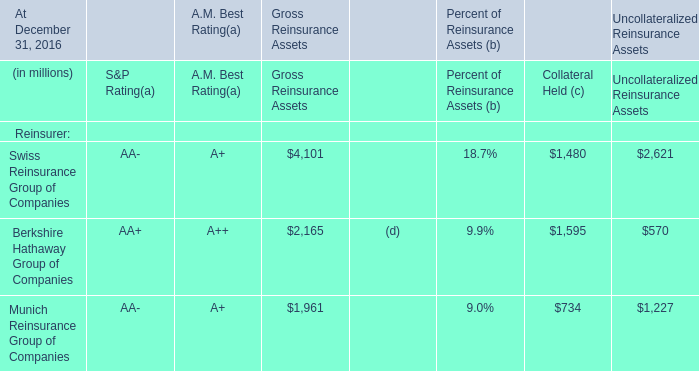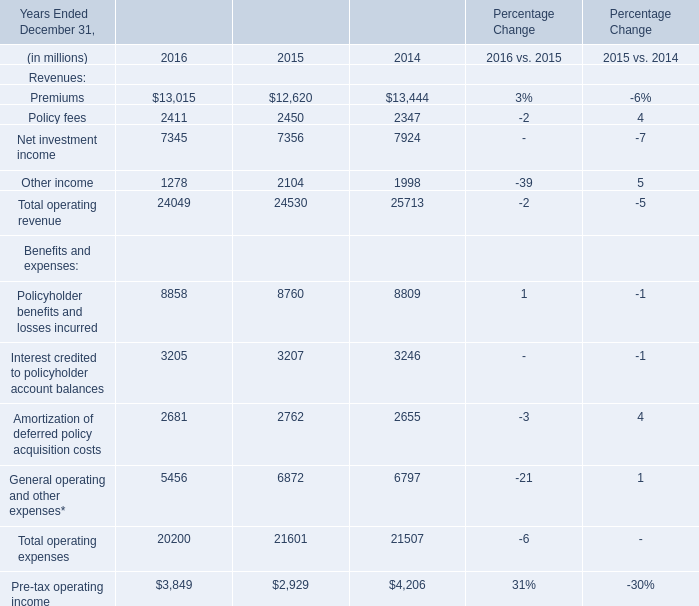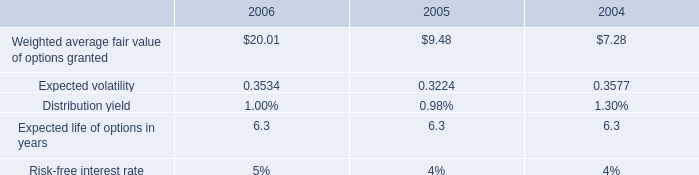considering the weighted average fair value of options , how many shares vested in 2004? 
Computations: (6418 / 7.28)
Answer: 881.59341. 